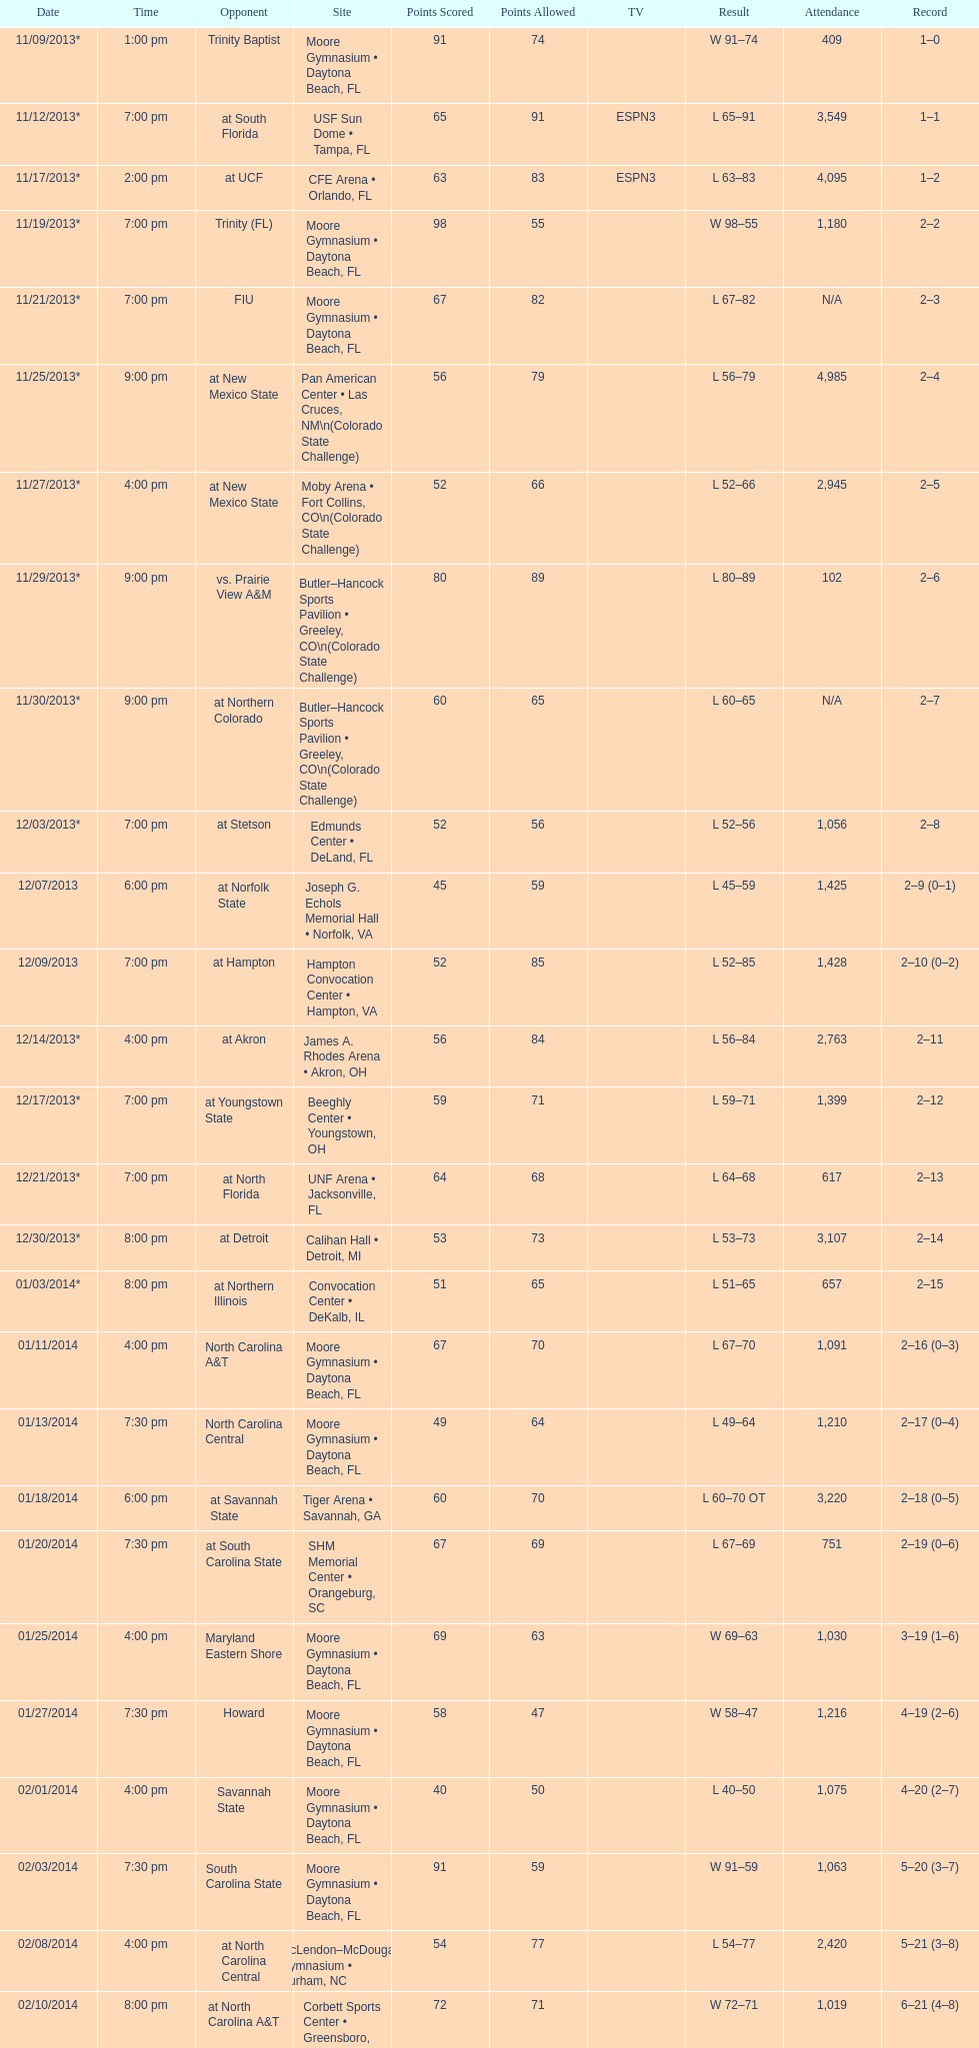What is the total attendance on 11/09/2013? 409. 